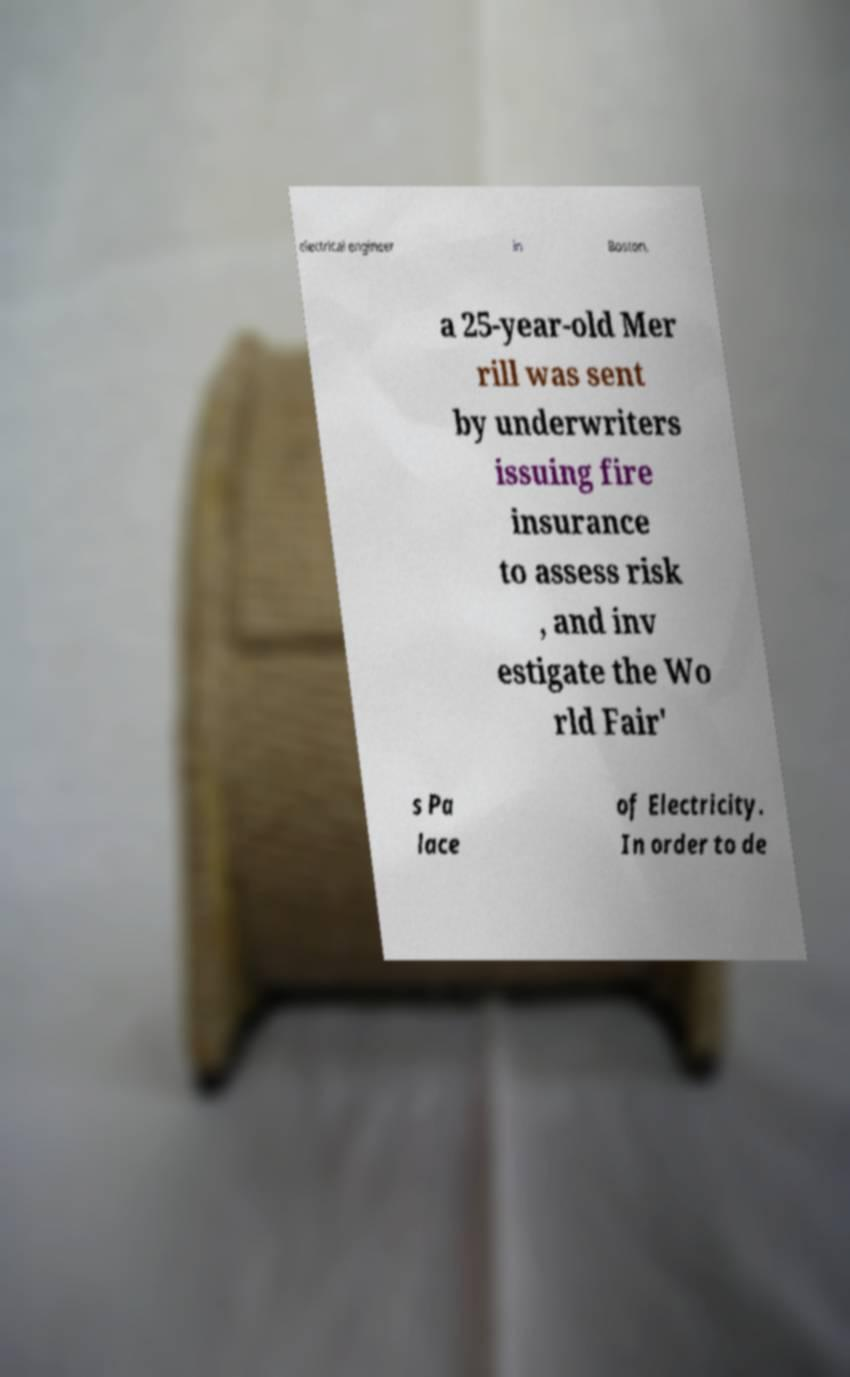Can you read and provide the text displayed in the image?This photo seems to have some interesting text. Can you extract and type it out for me? electrical engineer in Boston, a 25-year-old Mer rill was sent by underwriters issuing fire insurance to assess risk , and inv estigate the Wo rld Fair' s Pa lace of Electricity. In order to de 